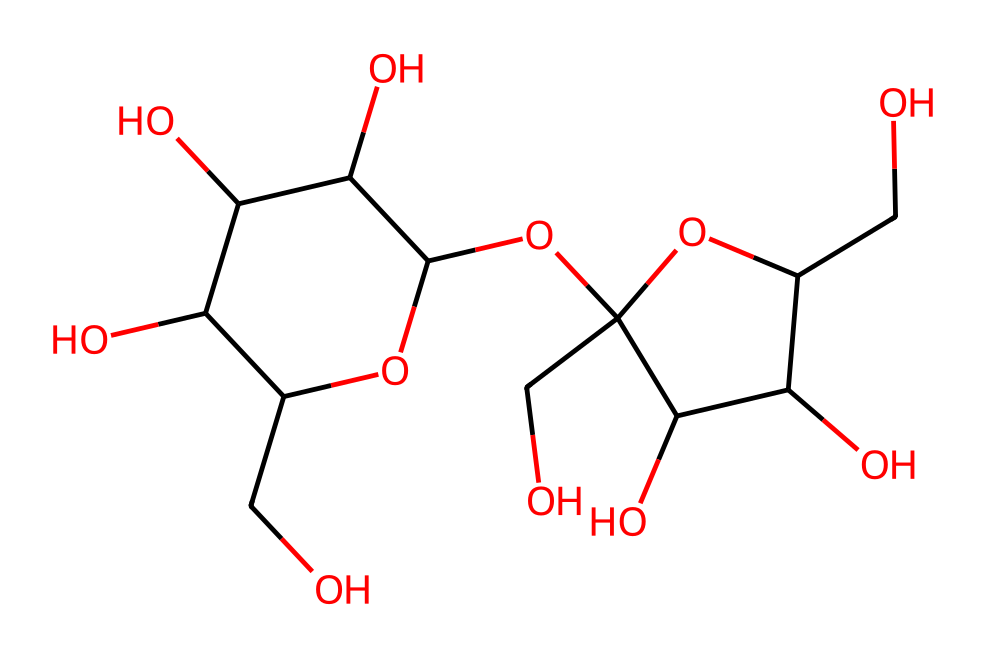What is the primary sugar component of maple syrup? The SMILES representation indicates a complex sugar structure similar to that of sucrose or fructose, which are known components in maple syrup. Specifically, looking at the structure derived from the SMILES, this compound resembles a disaccharide-like structure.
Answer: sucrose How many hydroxyl groups are present in this molecule? The structure can be analyzed for -OH groups, which correspond to hydroxyl groups. In this case, the visualization shows multiple -OH groups, and counting them reveals there are six hydroxyl groups in this structure.
Answer: six What type of carbohydrate is represented by this structure? Analyzing the structure based on its composition and arrangement, it appears to form a sugar molecule, specifically indicating that it is a polyol due to its multiple hydroxyl groups. Because of its structure, it can be identified as a polysaccharide component as well.
Answer: polysaccharide What is the molecular formula derived from the SMILES? The SMILES can be interpreted to obtain the molecular formula by counting each type of atom present in the structure, which shows a total of 12 carbons, 14 hydrogens, and 10 oxygens. Therefore, the empirical formula deduced is C12H14O10.
Answer: C12H14O10 How many rings are present in this chemical structure? By inspecting the chemical structure encoded in the SMILES, the presence of two distinct cyclic portions can be identified. Each of these cycles represents a ring structure within the molecule. Therefore, there are two rings present in total.
Answer: two 